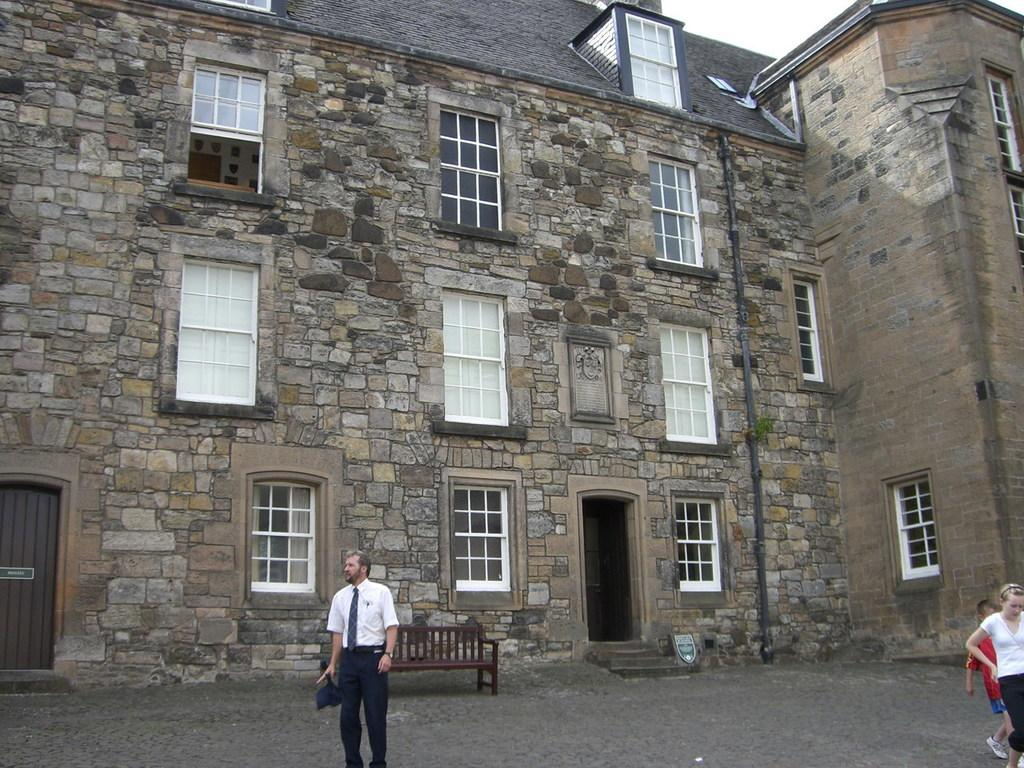What type of structure is present in the image? There is a building in the image. What features can be observed on the building? The building has windows and a door. Are there any people in the image? Yes, there are people in the image. What type of seating is available in front of the building? There is a bench in front of the building. What type of nerve is responsible for the people's ability to sit on the bench in the image? There is no mention of nerves or any biological processes in the image. The image only shows a building, people, and a bench. 